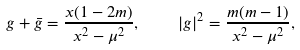Convert formula to latex. <formula><loc_0><loc_0><loc_500><loc_500>g + \bar { g } = \frac { x ( 1 - 2 m ) } { x ^ { 2 } - \mu ^ { 2 } } , \quad | g | ^ { 2 } = \frac { m ( m - 1 ) } { x ^ { 2 } - \mu ^ { 2 } } ,</formula> 